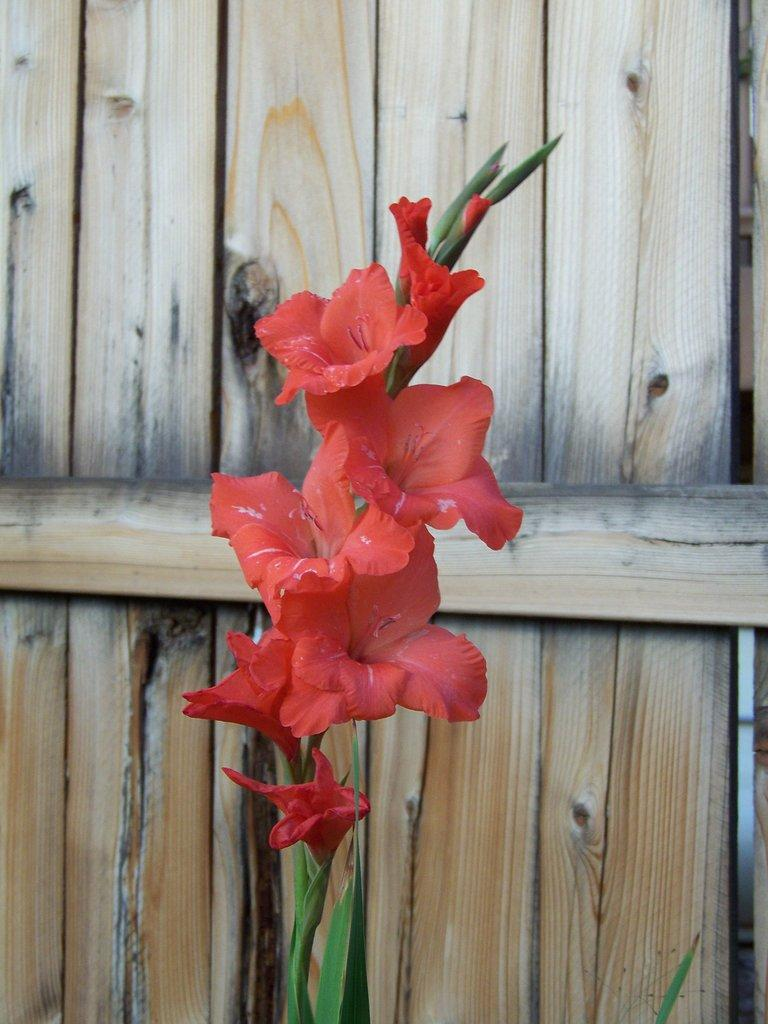What type of plant is in the image? There is a plant in the image. What features of the plant can be observed? The plant has flowers, leaves, and buds. What color are the flowers on the plant? The flowers on the plant are red in color. What is visible in the background of the image? There is a wooden door in the background of the image. What type of education can be seen being provided to the plant in the image? There is no education being provided to the plant in the image; it is a static image of a plant with flowers, leaves, and buds. 